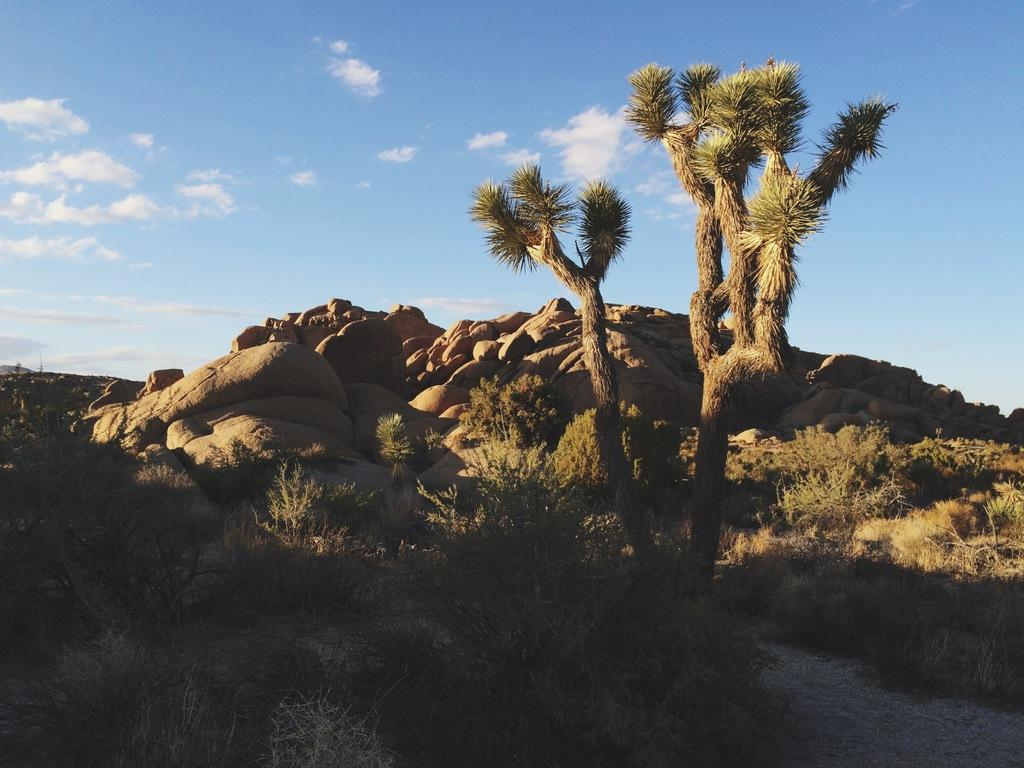What is the color of the sky in the image? The sky is blue in color. Are there any weather phenomena visible in the sky? Yes, there are clouds visible in the sky. What type of natural object can be seen in the image? There is a tree in the image. What other types of vegetation are present in the image? There are plants in the image. What geological features can be seen in the image? There are rocks in the image. Where is the store located in the image? There is no store present in the image. Are there any boys playing baseball in the image? There are no boys or baseball activity depicted in the image. 